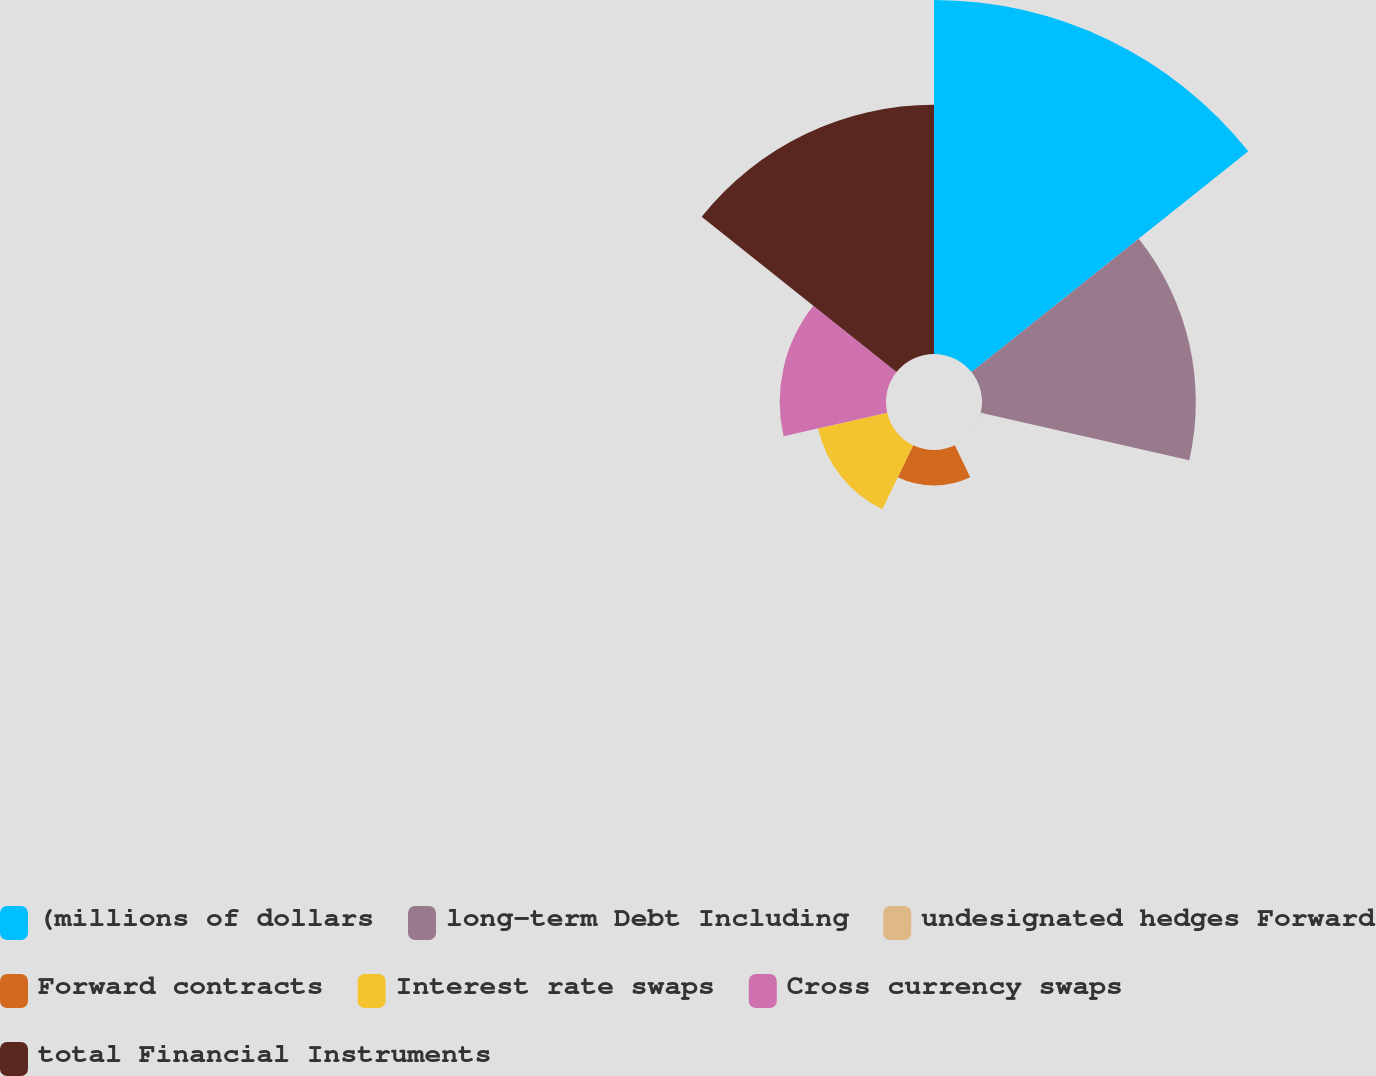Convert chart to OTSL. <chart><loc_0><loc_0><loc_500><loc_500><pie_chart><fcel>(millions of dollars<fcel>long-term Debt Including<fcel>undesignated hedges Forward<fcel>Forward contracts<fcel>Interest rate swaps<fcel>Cross currency swaps<fcel>total Financial Instruments<nl><fcel>34.37%<fcel>20.76%<fcel>0.02%<fcel>3.45%<fcel>6.89%<fcel>10.32%<fcel>24.19%<nl></chart> 